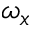Convert formula to latex. <formula><loc_0><loc_0><loc_500><loc_500>\omega _ { x }</formula> 